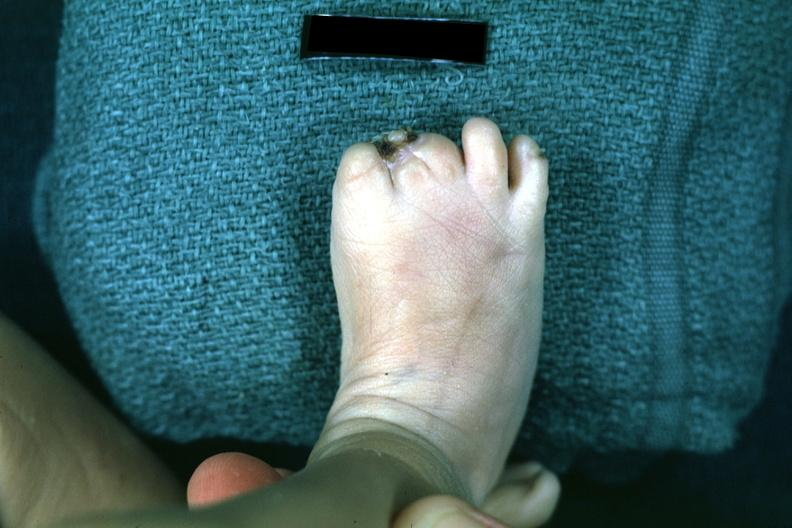does hemorrhage newborn show syndactyly?
Answer the question using a single word or phrase. No 